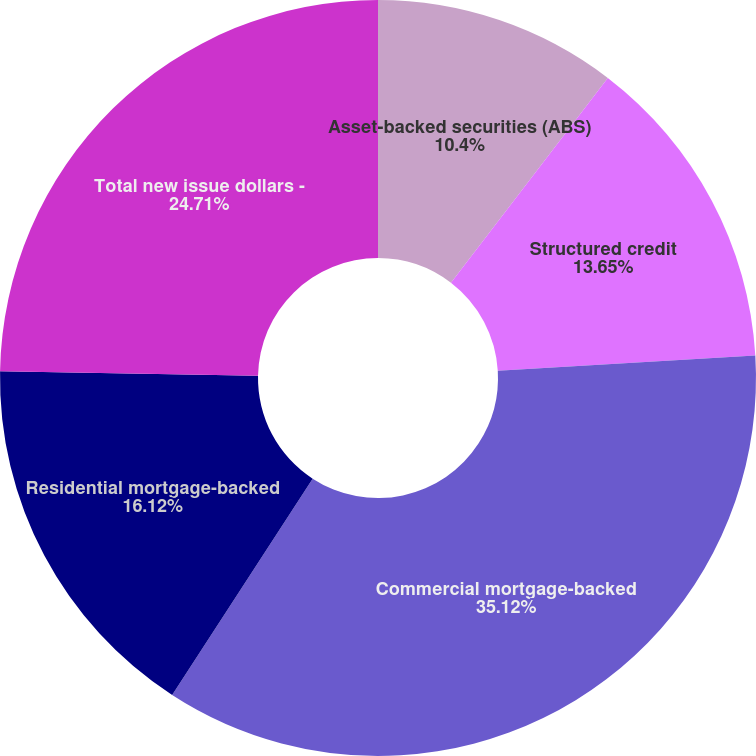<chart> <loc_0><loc_0><loc_500><loc_500><pie_chart><fcel>Asset-backed securities (ABS)<fcel>Structured credit<fcel>Commercial mortgage-backed<fcel>Residential mortgage-backed<fcel>Total new issue dollars -<nl><fcel>10.4%<fcel>13.65%<fcel>35.11%<fcel>16.12%<fcel>24.71%<nl></chart> 